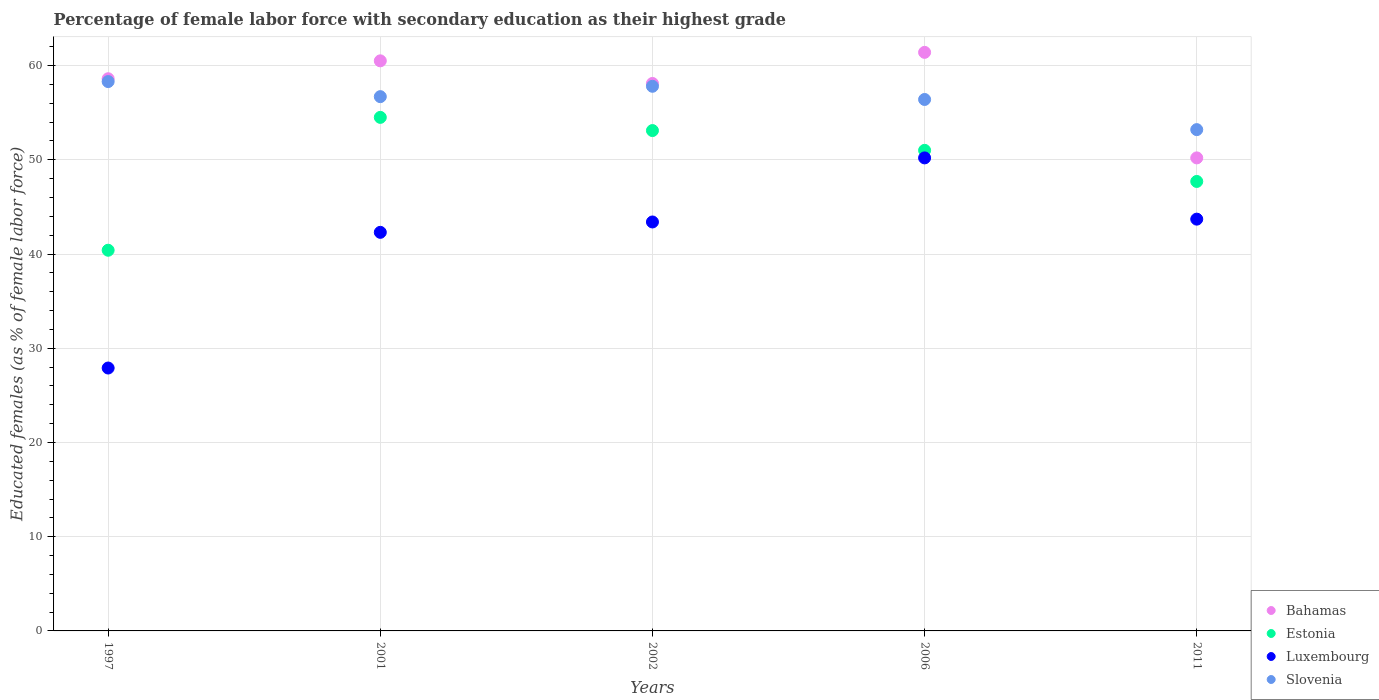Is the number of dotlines equal to the number of legend labels?
Give a very brief answer. Yes. What is the percentage of female labor force with secondary education in Luxembourg in 2002?
Offer a very short reply. 43.4. Across all years, what is the maximum percentage of female labor force with secondary education in Luxembourg?
Offer a terse response. 50.2. Across all years, what is the minimum percentage of female labor force with secondary education in Estonia?
Ensure brevity in your answer.  40.4. In which year was the percentage of female labor force with secondary education in Estonia minimum?
Your answer should be compact. 1997. What is the total percentage of female labor force with secondary education in Bahamas in the graph?
Make the answer very short. 288.8. What is the difference between the percentage of female labor force with secondary education in Slovenia in 1997 and that in 2011?
Provide a short and direct response. 5.1. What is the difference between the percentage of female labor force with secondary education in Estonia in 2011 and the percentage of female labor force with secondary education in Bahamas in 1997?
Your answer should be compact. -10.9. What is the average percentage of female labor force with secondary education in Estonia per year?
Provide a succinct answer. 49.34. In the year 2006, what is the difference between the percentage of female labor force with secondary education in Slovenia and percentage of female labor force with secondary education in Estonia?
Make the answer very short. 5.4. What is the ratio of the percentage of female labor force with secondary education in Bahamas in 1997 to that in 2002?
Give a very brief answer. 1.01. Is the difference between the percentage of female labor force with secondary education in Slovenia in 2002 and 2006 greater than the difference between the percentage of female labor force with secondary education in Estonia in 2002 and 2006?
Offer a terse response. No. What is the difference between the highest and the second highest percentage of female labor force with secondary education in Estonia?
Your answer should be compact. 1.4. What is the difference between the highest and the lowest percentage of female labor force with secondary education in Bahamas?
Offer a terse response. 11.2. Is it the case that in every year, the sum of the percentage of female labor force with secondary education in Bahamas and percentage of female labor force with secondary education in Luxembourg  is greater than the sum of percentage of female labor force with secondary education in Slovenia and percentage of female labor force with secondary education in Estonia?
Your response must be concise. No. Is it the case that in every year, the sum of the percentage of female labor force with secondary education in Slovenia and percentage of female labor force with secondary education in Luxembourg  is greater than the percentage of female labor force with secondary education in Bahamas?
Offer a terse response. Yes. Is the percentage of female labor force with secondary education in Luxembourg strictly greater than the percentage of female labor force with secondary education in Slovenia over the years?
Make the answer very short. No. Is the percentage of female labor force with secondary education in Slovenia strictly less than the percentage of female labor force with secondary education in Estonia over the years?
Your response must be concise. No. What is the difference between two consecutive major ticks on the Y-axis?
Your answer should be compact. 10. Are the values on the major ticks of Y-axis written in scientific E-notation?
Your answer should be very brief. No. How many legend labels are there?
Your answer should be very brief. 4. How are the legend labels stacked?
Offer a terse response. Vertical. What is the title of the graph?
Give a very brief answer. Percentage of female labor force with secondary education as their highest grade. What is the label or title of the Y-axis?
Ensure brevity in your answer.  Educated females (as % of female labor force). What is the Educated females (as % of female labor force) of Bahamas in 1997?
Ensure brevity in your answer.  58.6. What is the Educated females (as % of female labor force) in Estonia in 1997?
Keep it short and to the point. 40.4. What is the Educated females (as % of female labor force) in Luxembourg in 1997?
Ensure brevity in your answer.  27.9. What is the Educated females (as % of female labor force) in Slovenia in 1997?
Provide a succinct answer. 58.3. What is the Educated females (as % of female labor force) in Bahamas in 2001?
Your answer should be compact. 60.5. What is the Educated females (as % of female labor force) of Estonia in 2001?
Offer a very short reply. 54.5. What is the Educated females (as % of female labor force) of Luxembourg in 2001?
Offer a very short reply. 42.3. What is the Educated females (as % of female labor force) in Slovenia in 2001?
Offer a terse response. 56.7. What is the Educated females (as % of female labor force) in Bahamas in 2002?
Offer a very short reply. 58.1. What is the Educated females (as % of female labor force) in Estonia in 2002?
Make the answer very short. 53.1. What is the Educated females (as % of female labor force) in Luxembourg in 2002?
Ensure brevity in your answer.  43.4. What is the Educated females (as % of female labor force) in Slovenia in 2002?
Make the answer very short. 57.8. What is the Educated females (as % of female labor force) of Bahamas in 2006?
Provide a short and direct response. 61.4. What is the Educated females (as % of female labor force) in Luxembourg in 2006?
Provide a short and direct response. 50.2. What is the Educated females (as % of female labor force) of Slovenia in 2006?
Offer a very short reply. 56.4. What is the Educated females (as % of female labor force) in Bahamas in 2011?
Provide a succinct answer. 50.2. What is the Educated females (as % of female labor force) of Estonia in 2011?
Offer a terse response. 47.7. What is the Educated females (as % of female labor force) in Luxembourg in 2011?
Offer a very short reply. 43.7. What is the Educated females (as % of female labor force) in Slovenia in 2011?
Your answer should be compact. 53.2. Across all years, what is the maximum Educated females (as % of female labor force) of Bahamas?
Your answer should be compact. 61.4. Across all years, what is the maximum Educated females (as % of female labor force) of Estonia?
Ensure brevity in your answer.  54.5. Across all years, what is the maximum Educated females (as % of female labor force) in Luxembourg?
Ensure brevity in your answer.  50.2. Across all years, what is the maximum Educated females (as % of female labor force) in Slovenia?
Keep it short and to the point. 58.3. Across all years, what is the minimum Educated females (as % of female labor force) of Bahamas?
Make the answer very short. 50.2. Across all years, what is the minimum Educated females (as % of female labor force) of Estonia?
Ensure brevity in your answer.  40.4. Across all years, what is the minimum Educated females (as % of female labor force) of Luxembourg?
Offer a very short reply. 27.9. Across all years, what is the minimum Educated females (as % of female labor force) in Slovenia?
Ensure brevity in your answer.  53.2. What is the total Educated females (as % of female labor force) of Bahamas in the graph?
Your answer should be very brief. 288.8. What is the total Educated females (as % of female labor force) of Estonia in the graph?
Ensure brevity in your answer.  246.7. What is the total Educated females (as % of female labor force) of Luxembourg in the graph?
Keep it short and to the point. 207.5. What is the total Educated females (as % of female labor force) in Slovenia in the graph?
Give a very brief answer. 282.4. What is the difference between the Educated females (as % of female labor force) of Estonia in 1997 and that in 2001?
Your answer should be very brief. -14.1. What is the difference between the Educated females (as % of female labor force) of Luxembourg in 1997 and that in 2001?
Offer a very short reply. -14.4. What is the difference between the Educated females (as % of female labor force) in Slovenia in 1997 and that in 2001?
Offer a very short reply. 1.6. What is the difference between the Educated females (as % of female labor force) in Bahamas in 1997 and that in 2002?
Ensure brevity in your answer.  0.5. What is the difference between the Educated females (as % of female labor force) of Luxembourg in 1997 and that in 2002?
Your answer should be very brief. -15.5. What is the difference between the Educated females (as % of female labor force) of Bahamas in 1997 and that in 2006?
Provide a succinct answer. -2.8. What is the difference between the Educated females (as % of female labor force) of Estonia in 1997 and that in 2006?
Make the answer very short. -10.6. What is the difference between the Educated females (as % of female labor force) of Luxembourg in 1997 and that in 2006?
Your response must be concise. -22.3. What is the difference between the Educated females (as % of female labor force) in Estonia in 1997 and that in 2011?
Make the answer very short. -7.3. What is the difference between the Educated females (as % of female labor force) of Luxembourg in 1997 and that in 2011?
Keep it short and to the point. -15.8. What is the difference between the Educated females (as % of female labor force) in Slovenia in 1997 and that in 2011?
Offer a terse response. 5.1. What is the difference between the Educated females (as % of female labor force) of Estonia in 2001 and that in 2002?
Offer a very short reply. 1.4. What is the difference between the Educated females (as % of female labor force) of Luxembourg in 2001 and that in 2002?
Offer a very short reply. -1.1. What is the difference between the Educated females (as % of female labor force) of Slovenia in 2001 and that in 2002?
Your answer should be very brief. -1.1. What is the difference between the Educated females (as % of female labor force) of Estonia in 2001 and that in 2006?
Your answer should be compact. 3.5. What is the difference between the Educated females (as % of female labor force) in Slovenia in 2001 and that in 2006?
Offer a very short reply. 0.3. What is the difference between the Educated females (as % of female labor force) of Bahamas in 2001 and that in 2011?
Your answer should be very brief. 10.3. What is the difference between the Educated females (as % of female labor force) of Estonia in 2001 and that in 2011?
Your response must be concise. 6.8. What is the difference between the Educated females (as % of female labor force) in Luxembourg in 2001 and that in 2011?
Offer a terse response. -1.4. What is the difference between the Educated females (as % of female labor force) of Bahamas in 2002 and that in 2006?
Keep it short and to the point. -3.3. What is the difference between the Educated females (as % of female labor force) in Luxembourg in 2002 and that in 2006?
Offer a terse response. -6.8. What is the difference between the Educated females (as % of female labor force) of Slovenia in 2002 and that in 2006?
Your answer should be compact. 1.4. What is the difference between the Educated females (as % of female labor force) in Bahamas in 2002 and that in 2011?
Give a very brief answer. 7.9. What is the difference between the Educated females (as % of female labor force) of Slovenia in 2002 and that in 2011?
Offer a terse response. 4.6. What is the difference between the Educated females (as % of female labor force) of Bahamas in 2006 and that in 2011?
Provide a short and direct response. 11.2. What is the difference between the Educated females (as % of female labor force) in Estonia in 2006 and that in 2011?
Offer a very short reply. 3.3. What is the difference between the Educated females (as % of female labor force) of Slovenia in 2006 and that in 2011?
Offer a very short reply. 3.2. What is the difference between the Educated females (as % of female labor force) of Bahamas in 1997 and the Educated females (as % of female labor force) of Estonia in 2001?
Make the answer very short. 4.1. What is the difference between the Educated females (as % of female labor force) in Bahamas in 1997 and the Educated females (as % of female labor force) in Slovenia in 2001?
Make the answer very short. 1.9. What is the difference between the Educated females (as % of female labor force) in Estonia in 1997 and the Educated females (as % of female labor force) in Luxembourg in 2001?
Offer a very short reply. -1.9. What is the difference between the Educated females (as % of female labor force) of Estonia in 1997 and the Educated females (as % of female labor force) of Slovenia in 2001?
Offer a very short reply. -16.3. What is the difference between the Educated females (as % of female labor force) in Luxembourg in 1997 and the Educated females (as % of female labor force) in Slovenia in 2001?
Offer a very short reply. -28.8. What is the difference between the Educated females (as % of female labor force) in Bahamas in 1997 and the Educated females (as % of female labor force) in Estonia in 2002?
Offer a terse response. 5.5. What is the difference between the Educated females (as % of female labor force) in Bahamas in 1997 and the Educated females (as % of female labor force) in Luxembourg in 2002?
Your response must be concise. 15.2. What is the difference between the Educated females (as % of female labor force) in Estonia in 1997 and the Educated females (as % of female labor force) in Luxembourg in 2002?
Your response must be concise. -3. What is the difference between the Educated females (as % of female labor force) of Estonia in 1997 and the Educated females (as % of female labor force) of Slovenia in 2002?
Give a very brief answer. -17.4. What is the difference between the Educated females (as % of female labor force) of Luxembourg in 1997 and the Educated females (as % of female labor force) of Slovenia in 2002?
Your answer should be compact. -29.9. What is the difference between the Educated females (as % of female labor force) in Luxembourg in 1997 and the Educated females (as % of female labor force) in Slovenia in 2006?
Make the answer very short. -28.5. What is the difference between the Educated females (as % of female labor force) in Bahamas in 1997 and the Educated females (as % of female labor force) in Slovenia in 2011?
Your answer should be compact. 5.4. What is the difference between the Educated females (as % of female labor force) in Estonia in 1997 and the Educated females (as % of female labor force) in Luxembourg in 2011?
Provide a short and direct response. -3.3. What is the difference between the Educated females (as % of female labor force) in Luxembourg in 1997 and the Educated females (as % of female labor force) in Slovenia in 2011?
Your answer should be very brief. -25.3. What is the difference between the Educated females (as % of female labor force) in Luxembourg in 2001 and the Educated females (as % of female labor force) in Slovenia in 2002?
Your response must be concise. -15.5. What is the difference between the Educated females (as % of female labor force) of Bahamas in 2001 and the Educated females (as % of female labor force) of Estonia in 2006?
Keep it short and to the point. 9.5. What is the difference between the Educated females (as % of female labor force) in Bahamas in 2001 and the Educated females (as % of female labor force) in Luxembourg in 2006?
Your response must be concise. 10.3. What is the difference between the Educated females (as % of female labor force) in Bahamas in 2001 and the Educated females (as % of female labor force) in Slovenia in 2006?
Your answer should be very brief. 4.1. What is the difference between the Educated females (as % of female labor force) of Estonia in 2001 and the Educated females (as % of female labor force) of Luxembourg in 2006?
Your answer should be very brief. 4.3. What is the difference between the Educated females (as % of female labor force) in Estonia in 2001 and the Educated females (as % of female labor force) in Slovenia in 2006?
Keep it short and to the point. -1.9. What is the difference between the Educated females (as % of female labor force) in Luxembourg in 2001 and the Educated females (as % of female labor force) in Slovenia in 2006?
Offer a very short reply. -14.1. What is the difference between the Educated females (as % of female labor force) in Bahamas in 2001 and the Educated females (as % of female labor force) in Estonia in 2011?
Make the answer very short. 12.8. What is the difference between the Educated females (as % of female labor force) in Bahamas in 2001 and the Educated females (as % of female labor force) in Luxembourg in 2011?
Your response must be concise. 16.8. What is the difference between the Educated females (as % of female labor force) in Bahamas in 2001 and the Educated females (as % of female labor force) in Slovenia in 2011?
Keep it short and to the point. 7.3. What is the difference between the Educated females (as % of female labor force) of Bahamas in 2002 and the Educated females (as % of female labor force) of Estonia in 2006?
Your answer should be compact. 7.1. What is the difference between the Educated females (as % of female labor force) of Bahamas in 2002 and the Educated females (as % of female labor force) of Luxembourg in 2006?
Keep it short and to the point. 7.9. What is the difference between the Educated females (as % of female labor force) of Estonia in 2002 and the Educated females (as % of female labor force) of Luxembourg in 2006?
Keep it short and to the point. 2.9. What is the difference between the Educated females (as % of female labor force) of Estonia in 2002 and the Educated females (as % of female labor force) of Slovenia in 2006?
Give a very brief answer. -3.3. What is the difference between the Educated females (as % of female labor force) of Bahamas in 2002 and the Educated females (as % of female labor force) of Estonia in 2011?
Provide a short and direct response. 10.4. What is the difference between the Educated females (as % of female labor force) of Bahamas in 2002 and the Educated females (as % of female labor force) of Slovenia in 2011?
Keep it short and to the point. 4.9. What is the difference between the Educated females (as % of female labor force) in Estonia in 2002 and the Educated females (as % of female labor force) in Slovenia in 2011?
Ensure brevity in your answer.  -0.1. What is the difference between the Educated females (as % of female labor force) in Bahamas in 2006 and the Educated females (as % of female labor force) in Luxembourg in 2011?
Keep it short and to the point. 17.7. What is the difference between the Educated females (as % of female labor force) in Estonia in 2006 and the Educated females (as % of female labor force) in Luxembourg in 2011?
Provide a succinct answer. 7.3. What is the difference between the Educated females (as % of female labor force) of Luxembourg in 2006 and the Educated females (as % of female labor force) of Slovenia in 2011?
Ensure brevity in your answer.  -3. What is the average Educated females (as % of female labor force) in Bahamas per year?
Provide a short and direct response. 57.76. What is the average Educated females (as % of female labor force) in Estonia per year?
Your response must be concise. 49.34. What is the average Educated females (as % of female labor force) in Luxembourg per year?
Give a very brief answer. 41.5. What is the average Educated females (as % of female labor force) of Slovenia per year?
Keep it short and to the point. 56.48. In the year 1997, what is the difference between the Educated females (as % of female labor force) in Bahamas and Educated females (as % of female labor force) in Estonia?
Make the answer very short. 18.2. In the year 1997, what is the difference between the Educated females (as % of female labor force) of Bahamas and Educated females (as % of female labor force) of Luxembourg?
Ensure brevity in your answer.  30.7. In the year 1997, what is the difference between the Educated females (as % of female labor force) in Bahamas and Educated females (as % of female labor force) in Slovenia?
Give a very brief answer. 0.3. In the year 1997, what is the difference between the Educated females (as % of female labor force) in Estonia and Educated females (as % of female labor force) in Luxembourg?
Your answer should be very brief. 12.5. In the year 1997, what is the difference between the Educated females (as % of female labor force) in Estonia and Educated females (as % of female labor force) in Slovenia?
Provide a succinct answer. -17.9. In the year 1997, what is the difference between the Educated females (as % of female labor force) in Luxembourg and Educated females (as % of female labor force) in Slovenia?
Make the answer very short. -30.4. In the year 2001, what is the difference between the Educated females (as % of female labor force) of Luxembourg and Educated females (as % of female labor force) of Slovenia?
Offer a very short reply. -14.4. In the year 2002, what is the difference between the Educated females (as % of female labor force) of Bahamas and Educated females (as % of female labor force) of Estonia?
Offer a very short reply. 5. In the year 2002, what is the difference between the Educated females (as % of female labor force) in Bahamas and Educated females (as % of female labor force) in Slovenia?
Your response must be concise. 0.3. In the year 2002, what is the difference between the Educated females (as % of female labor force) of Estonia and Educated females (as % of female labor force) of Slovenia?
Give a very brief answer. -4.7. In the year 2002, what is the difference between the Educated females (as % of female labor force) of Luxembourg and Educated females (as % of female labor force) of Slovenia?
Your answer should be very brief. -14.4. In the year 2006, what is the difference between the Educated females (as % of female labor force) of Luxembourg and Educated females (as % of female labor force) of Slovenia?
Your response must be concise. -6.2. In the year 2011, what is the difference between the Educated females (as % of female labor force) in Bahamas and Educated females (as % of female labor force) in Estonia?
Your answer should be compact. 2.5. In the year 2011, what is the difference between the Educated females (as % of female labor force) of Bahamas and Educated females (as % of female labor force) of Luxembourg?
Your answer should be very brief. 6.5. In the year 2011, what is the difference between the Educated females (as % of female labor force) of Estonia and Educated females (as % of female labor force) of Luxembourg?
Provide a short and direct response. 4. In the year 2011, what is the difference between the Educated females (as % of female labor force) in Estonia and Educated females (as % of female labor force) in Slovenia?
Your answer should be very brief. -5.5. In the year 2011, what is the difference between the Educated females (as % of female labor force) of Luxembourg and Educated females (as % of female labor force) of Slovenia?
Your answer should be compact. -9.5. What is the ratio of the Educated females (as % of female labor force) in Bahamas in 1997 to that in 2001?
Offer a terse response. 0.97. What is the ratio of the Educated females (as % of female labor force) of Estonia in 1997 to that in 2001?
Your response must be concise. 0.74. What is the ratio of the Educated females (as % of female labor force) in Luxembourg in 1997 to that in 2001?
Your answer should be compact. 0.66. What is the ratio of the Educated females (as % of female labor force) in Slovenia in 1997 to that in 2001?
Your response must be concise. 1.03. What is the ratio of the Educated females (as % of female labor force) of Bahamas in 1997 to that in 2002?
Offer a terse response. 1.01. What is the ratio of the Educated females (as % of female labor force) in Estonia in 1997 to that in 2002?
Offer a terse response. 0.76. What is the ratio of the Educated females (as % of female labor force) in Luxembourg in 1997 to that in 2002?
Your response must be concise. 0.64. What is the ratio of the Educated females (as % of female labor force) in Slovenia in 1997 to that in 2002?
Keep it short and to the point. 1.01. What is the ratio of the Educated females (as % of female labor force) in Bahamas in 1997 to that in 2006?
Offer a very short reply. 0.95. What is the ratio of the Educated females (as % of female labor force) in Estonia in 1997 to that in 2006?
Your answer should be compact. 0.79. What is the ratio of the Educated females (as % of female labor force) in Luxembourg in 1997 to that in 2006?
Offer a very short reply. 0.56. What is the ratio of the Educated females (as % of female labor force) in Slovenia in 1997 to that in 2006?
Ensure brevity in your answer.  1.03. What is the ratio of the Educated females (as % of female labor force) of Bahamas in 1997 to that in 2011?
Your response must be concise. 1.17. What is the ratio of the Educated females (as % of female labor force) in Estonia in 1997 to that in 2011?
Your response must be concise. 0.85. What is the ratio of the Educated females (as % of female labor force) of Luxembourg in 1997 to that in 2011?
Offer a very short reply. 0.64. What is the ratio of the Educated females (as % of female labor force) in Slovenia in 1997 to that in 2011?
Your response must be concise. 1.1. What is the ratio of the Educated females (as % of female labor force) of Bahamas in 2001 to that in 2002?
Provide a short and direct response. 1.04. What is the ratio of the Educated females (as % of female labor force) in Estonia in 2001 to that in 2002?
Keep it short and to the point. 1.03. What is the ratio of the Educated females (as % of female labor force) in Luxembourg in 2001 to that in 2002?
Provide a succinct answer. 0.97. What is the ratio of the Educated females (as % of female labor force) of Bahamas in 2001 to that in 2006?
Keep it short and to the point. 0.99. What is the ratio of the Educated females (as % of female labor force) of Estonia in 2001 to that in 2006?
Your answer should be compact. 1.07. What is the ratio of the Educated females (as % of female labor force) of Luxembourg in 2001 to that in 2006?
Offer a terse response. 0.84. What is the ratio of the Educated females (as % of female labor force) in Bahamas in 2001 to that in 2011?
Your answer should be very brief. 1.21. What is the ratio of the Educated females (as % of female labor force) of Estonia in 2001 to that in 2011?
Keep it short and to the point. 1.14. What is the ratio of the Educated females (as % of female labor force) in Luxembourg in 2001 to that in 2011?
Make the answer very short. 0.97. What is the ratio of the Educated females (as % of female labor force) of Slovenia in 2001 to that in 2011?
Your answer should be very brief. 1.07. What is the ratio of the Educated females (as % of female labor force) of Bahamas in 2002 to that in 2006?
Your answer should be very brief. 0.95. What is the ratio of the Educated females (as % of female labor force) of Estonia in 2002 to that in 2006?
Offer a terse response. 1.04. What is the ratio of the Educated females (as % of female labor force) in Luxembourg in 2002 to that in 2006?
Ensure brevity in your answer.  0.86. What is the ratio of the Educated females (as % of female labor force) in Slovenia in 2002 to that in 2006?
Your answer should be very brief. 1.02. What is the ratio of the Educated females (as % of female labor force) of Bahamas in 2002 to that in 2011?
Make the answer very short. 1.16. What is the ratio of the Educated females (as % of female labor force) of Estonia in 2002 to that in 2011?
Make the answer very short. 1.11. What is the ratio of the Educated females (as % of female labor force) of Luxembourg in 2002 to that in 2011?
Make the answer very short. 0.99. What is the ratio of the Educated females (as % of female labor force) in Slovenia in 2002 to that in 2011?
Keep it short and to the point. 1.09. What is the ratio of the Educated females (as % of female labor force) of Bahamas in 2006 to that in 2011?
Make the answer very short. 1.22. What is the ratio of the Educated females (as % of female labor force) of Estonia in 2006 to that in 2011?
Give a very brief answer. 1.07. What is the ratio of the Educated females (as % of female labor force) in Luxembourg in 2006 to that in 2011?
Your answer should be compact. 1.15. What is the ratio of the Educated females (as % of female labor force) in Slovenia in 2006 to that in 2011?
Offer a very short reply. 1.06. What is the difference between the highest and the lowest Educated females (as % of female labor force) of Estonia?
Your answer should be very brief. 14.1. What is the difference between the highest and the lowest Educated females (as % of female labor force) in Luxembourg?
Offer a terse response. 22.3. 